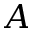Convert formula to latex. <formula><loc_0><loc_0><loc_500><loc_500>A</formula> 